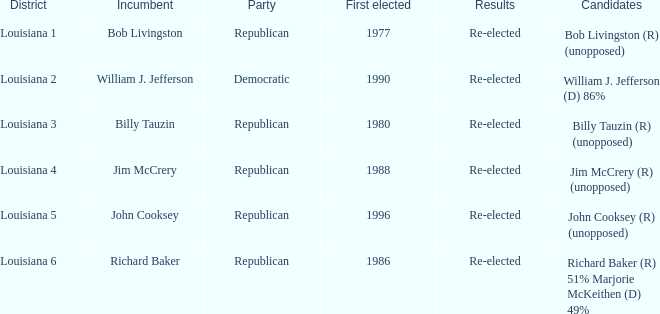How many candidates were elected first in 1980? 1.0. 